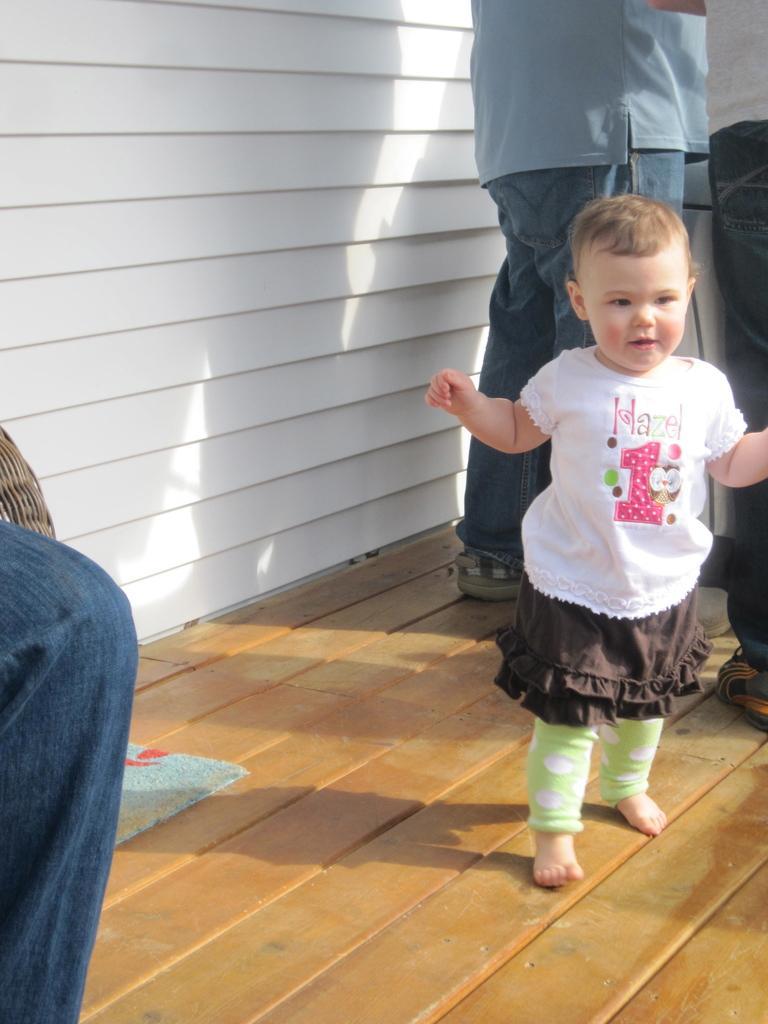How would you summarize this image in a sentence or two? On this wooden surface there is a mat, people and kid. This is white wall. 